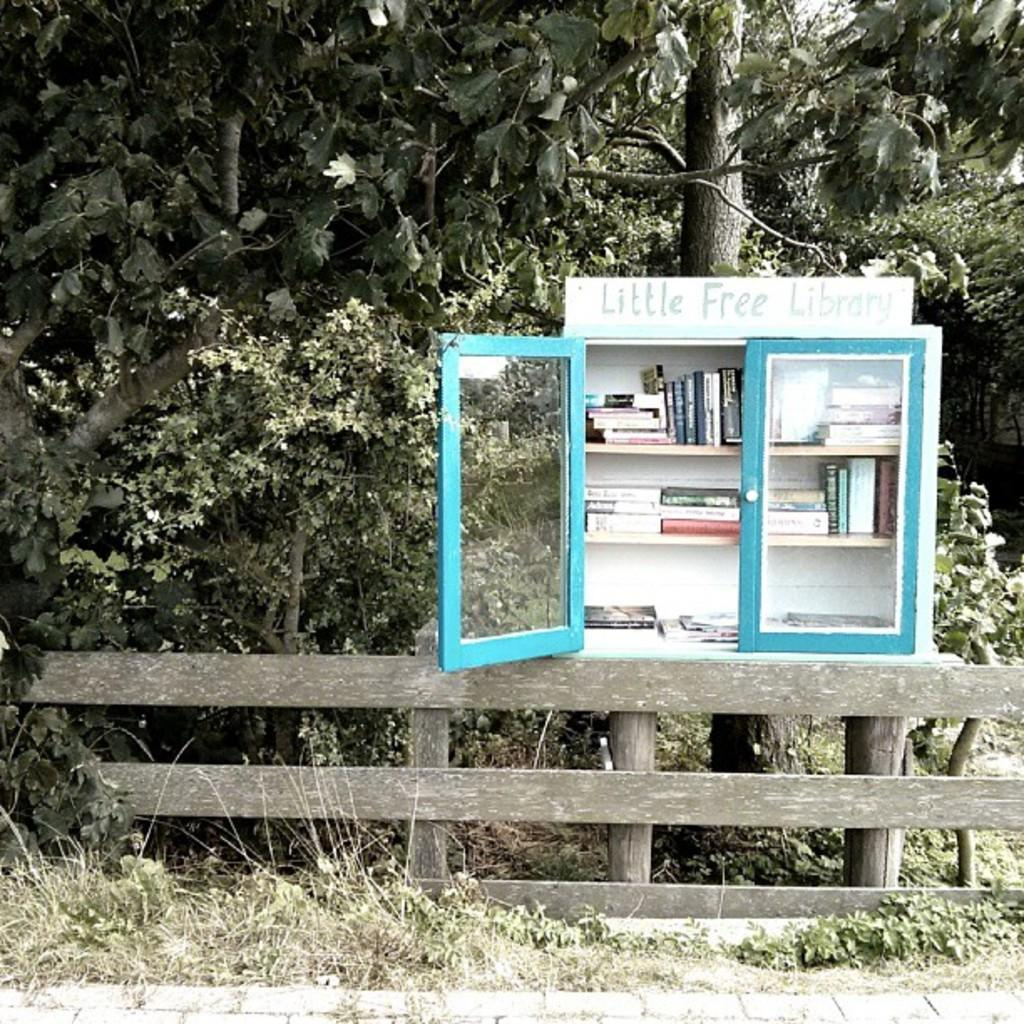Provide a one-sentence caption for the provided image. A Little Free Library case with books sits on the side of the road. 